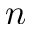<formula> <loc_0><loc_0><loc_500><loc_500>n</formula> 